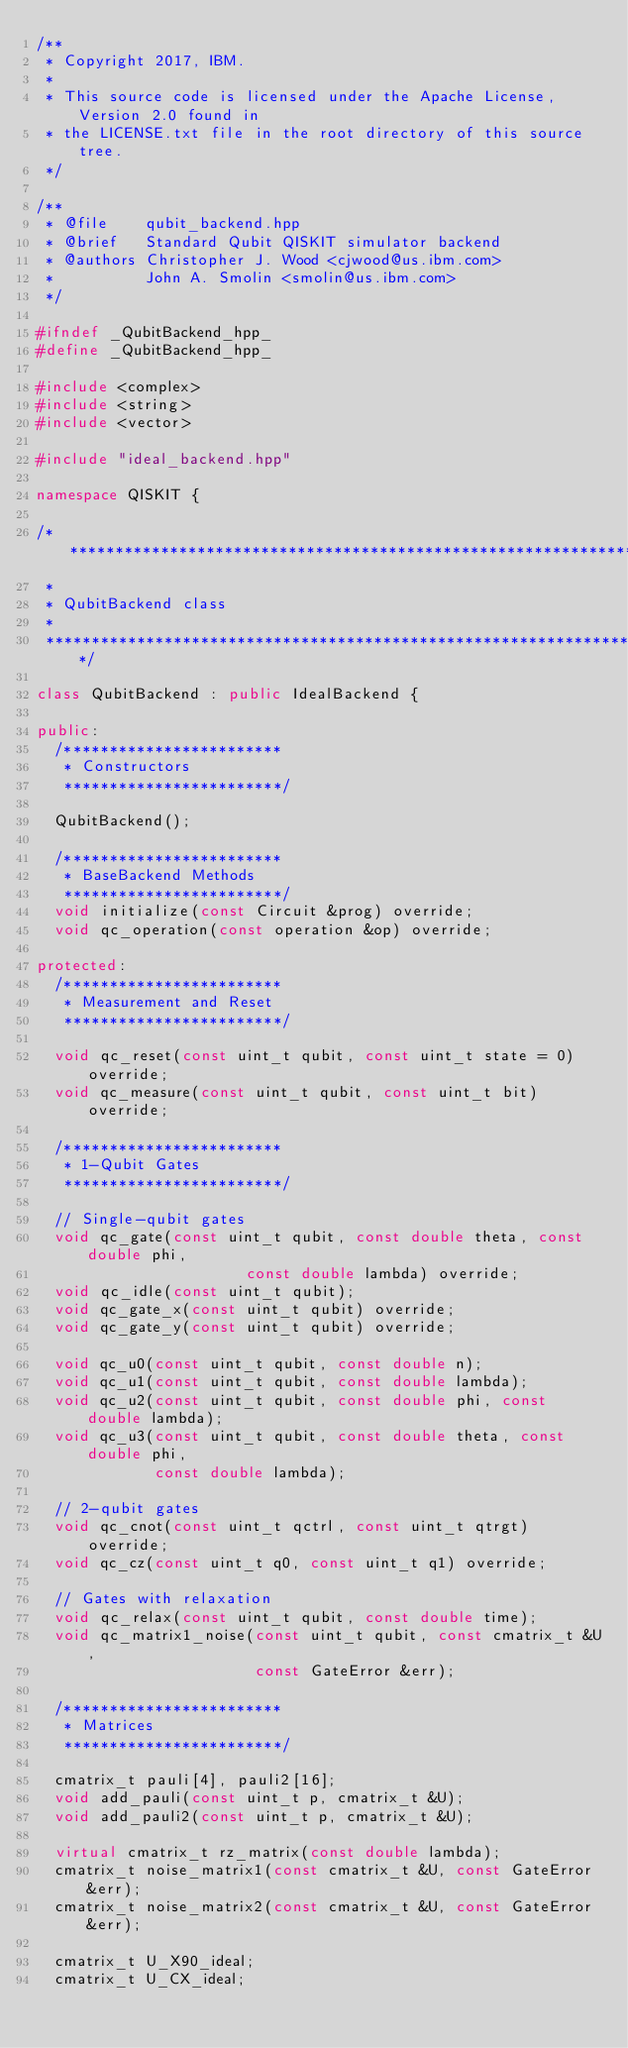<code> <loc_0><loc_0><loc_500><loc_500><_C++_>/**
 * Copyright 2017, IBM.
 *
 * This source code is licensed under the Apache License, Version 2.0 found in
 * the LICENSE.txt file in the root directory of this source tree.
 */

/**
 * @file    qubit_backend.hpp
 * @brief   Standard Qubit QISKIT simulator backend
 * @authors Christopher J. Wood <cjwood@us.ibm.com>
 *          John A. Smolin <smolin@us.ibm.com>
 */

#ifndef _QubitBackend_hpp_
#define _QubitBackend_hpp_

#include <complex>
#include <string>
#include <vector>

#include "ideal_backend.hpp"

namespace QISKIT {

/*******************************************************************************
 *
 * QubitBackend class
 *
 ******************************************************************************/

class QubitBackend : public IdealBackend {

public:
  /************************
   * Constructors
   ************************/

  QubitBackend();

  /************************
   * BaseBackend Methods
   ************************/
  void initialize(const Circuit &prog) override;
  void qc_operation(const operation &op) override;

protected:
  /************************
   * Measurement and Reset
   ************************/

  void qc_reset(const uint_t qubit, const uint_t state = 0) override;
  void qc_measure(const uint_t qubit, const uint_t bit) override;

  /************************
   * 1-Qubit Gates
   ************************/

  // Single-qubit gates
  void qc_gate(const uint_t qubit, const double theta, const double phi,
                       const double lambda) override;
  void qc_idle(const uint_t qubit);
  void qc_gate_x(const uint_t qubit) override;
  void qc_gate_y(const uint_t qubit) override;

  void qc_u0(const uint_t qubit, const double n);
  void qc_u1(const uint_t qubit, const double lambda);
  void qc_u2(const uint_t qubit, const double phi, const double lambda);
  void qc_u3(const uint_t qubit, const double theta, const double phi,
             const double lambda);

  // 2-qubit gates
  void qc_cnot(const uint_t qctrl, const uint_t qtrgt) override;
  void qc_cz(const uint_t q0, const uint_t q1) override;

  // Gates with relaxation
  void qc_relax(const uint_t qubit, const double time);
  void qc_matrix1_noise(const uint_t qubit, const cmatrix_t &U,
                        const GateError &err);

  /************************
   * Matrices
   ************************/

  cmatrix_t pauli[4], pauli2[16];
  void add_pauli(const uint_t p, cmatrix_t &U);
  void add_pauli2(const uint_t p, cmatrix_t &U);

  virtual cmatrix_t rz_matrix(const double lambda);
  cmatrix_t noise_matrix1(const cmatrix_t &U, const GateError &err);
  cmatrix_t noise_matrix2(const cmatrix_t &U, const GateError &err);

  cmatrix_t U_X90_ideal;
  cmatrix_t U_CX_ideal;</code> 